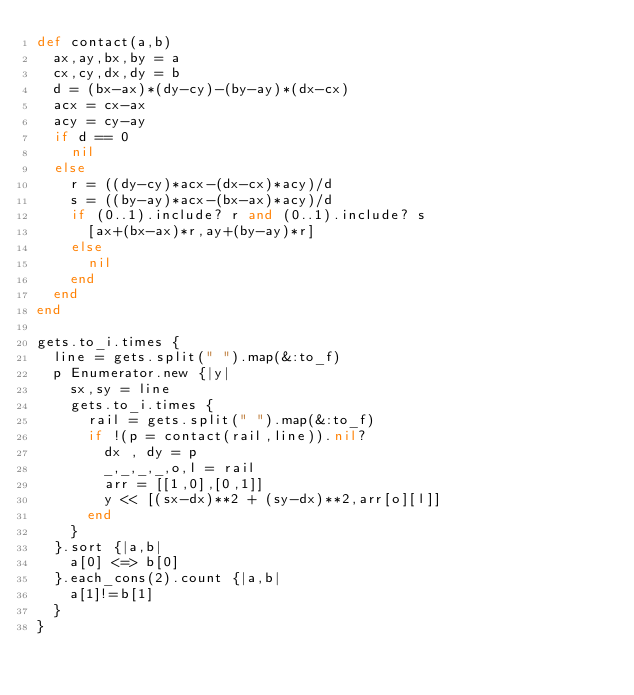Convert code to text. <code><loc_0><loc_0><loc_500><loc_500><_Ruby_>def contact(a,b)
	ax,ay,bx,by = a
	cx,cy,dx,dy = b
	d = (bx-ax)*(dy-cy)-(by-ay)*(dx-cx)
	acx = cx-ax
	acy = cy-ay
	if d == 0
		nil
	else
		r = ((dy-cy)*acx-(dx-cx)*acy)/d
		s = ((by-ay)*acx-(bx-ax)*acy)/d
		if (0..1).include? r and (0..1).include? s
			[ax+(bx-ax)*r,ay+(by-ay)*r]
		else
			nil
		end
	end
end

gets.to_i.times {
	line = gets.split(" ").map(&:to_f)
	p Enumerator.new {|y|
		sx,sy = line
		gets.to_i.times {
			rail = gets.split(" ").map(&:to_f)
			if !(p = contact(rail,line)).nil?
				dx , dy = p
				_,_,_,_,o,l = rail
				arr = [[1,0],[0,1]]
				y << [(sx-dx)**2 + (sy-dx)**2,arr[o][l]]
			end
		}
	}.sort {|a,b|
		a[0] <=> b[0]
	}.each_cons(2).count {|a,b|
		a[1]!=b[1]
	}
}</code> 